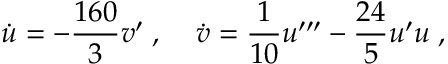<formula> <loc_0><loc_0><loc_500><loc_500>\dot { u } = - { \frac { 1 6 0 } { 3 } } v ^ { \prime } \, , \, \dot { v } = { \frac { 1 } { 1 0 } } u ^ { \prime \prime \prime } - { \frac { 2 4 } { 5 } } u ^ { \prime } u \, ,</formula> 